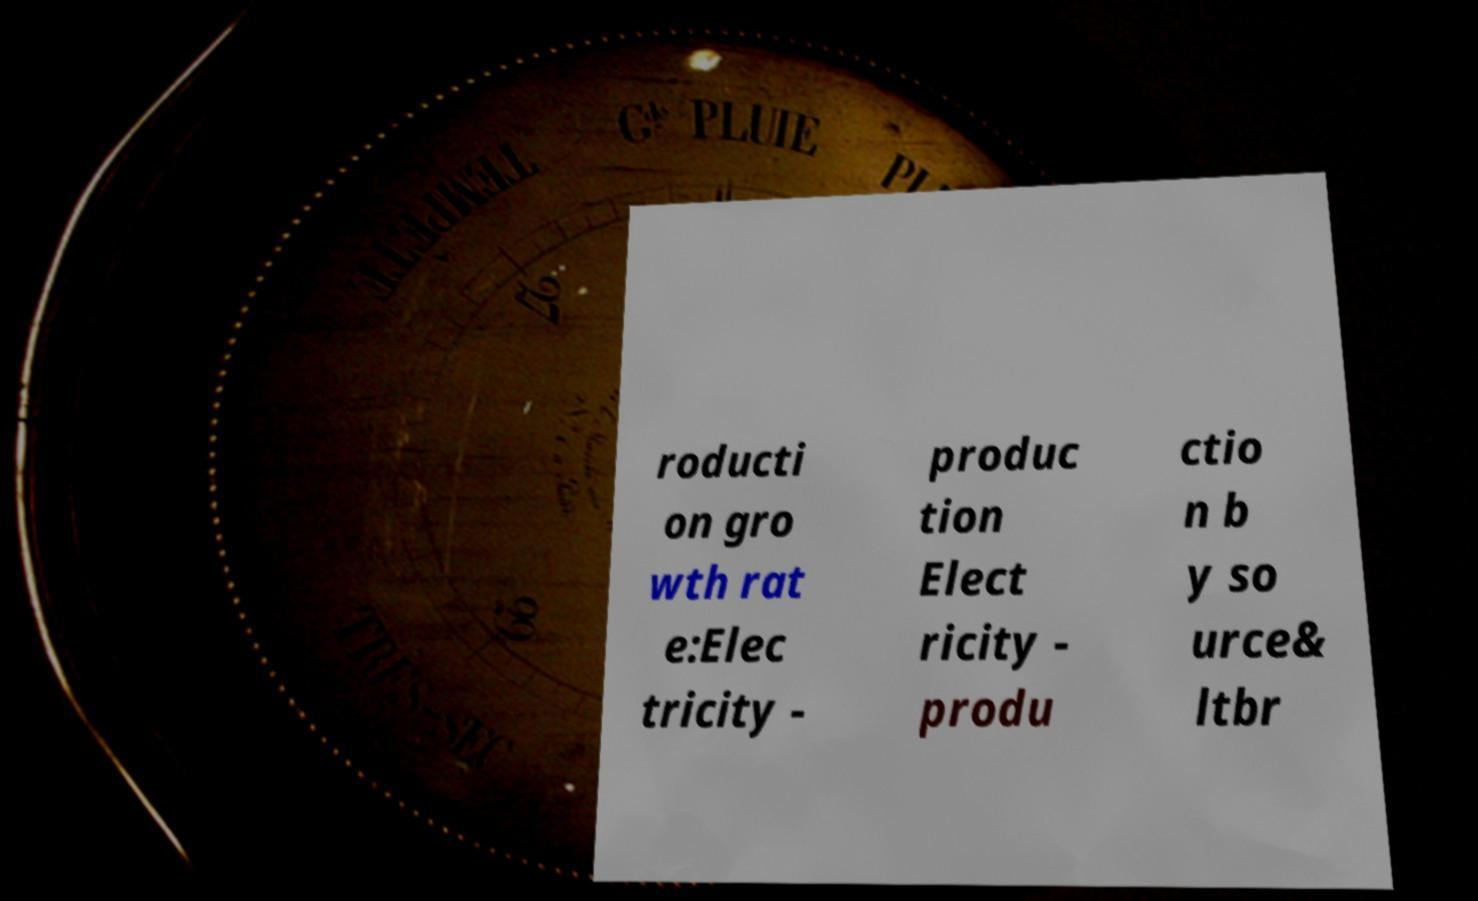What messages or text are displayed in this image? I need them in a readable, typed format. roducti on gro wth rat e:Elec tricity - produc tion Elect ricity - produ ctio n b y so urce& ltbr 